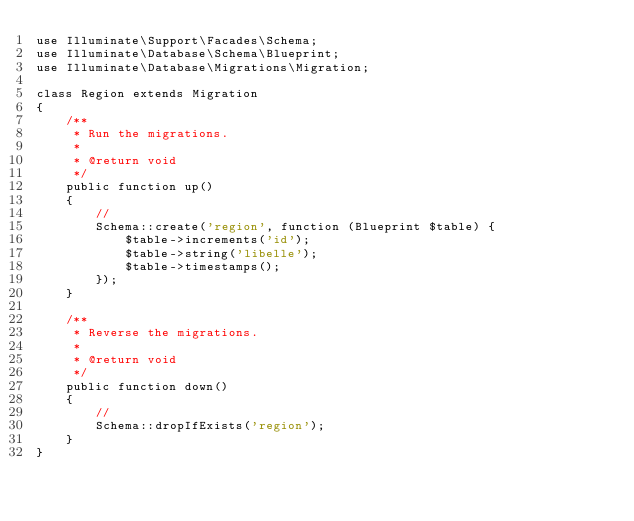<code> <loc_0><loc_0><loc_500><loc_500><_PHP_>use Illuminate\Support\Facades\Schema;
use Illuminate\Database\Schema\Blueprint;
use Illuminate\Database\Migrations\Migration;

class Region extends Migration
{
    /**
     * Run the migrations.
     *
     * @return void
     */
    public function up()
    {
        //
        Schema::create('region', function (Blueprint $table) {
            $table->increments('id');
            $table->string('libelle');
            $table->timestamps();
        });
    }

    /**
     * Reverse the migrations.
     *
     * @return void
     */
    public function down()
    {
        //
        Schema::dropIfExists('region');
    }
}
</code> 